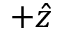Convert formula to latex. <formula><loc_0><loc_0><loc_500><loc_500>+ \hat { z }</formula> 